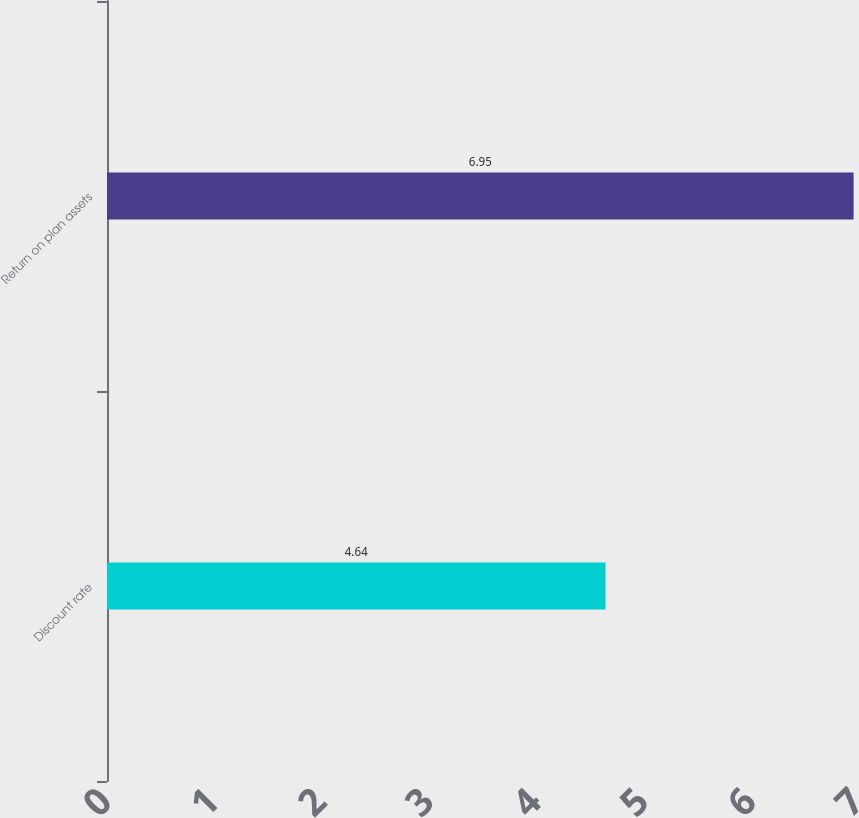<chart> <loc_0><loc_0><loc_500><loc_500><bar_chart><fcel>Discount rate<fcel>Return on plan assets<nl><fcel>4.64<fcel>6.95<nl></chart> 